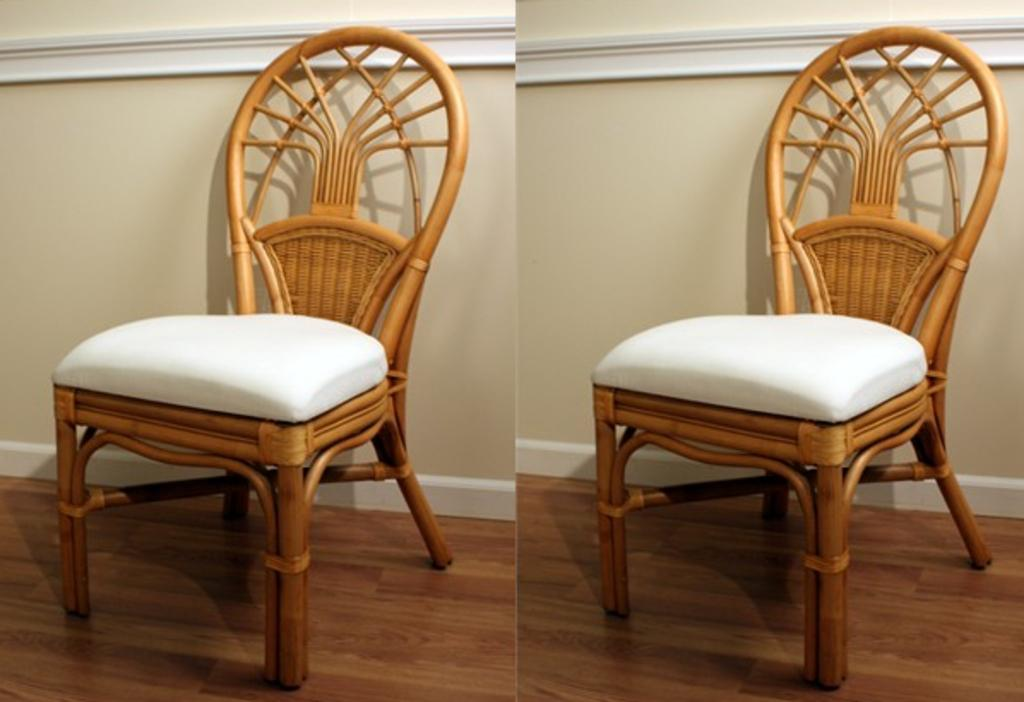What type of chair is in the image? There is a wooden chair in the image. Where is the wooden chair located? The wooden chair is placed on the wooden floor. What can be seen in the background of the image? There is a wall visible in the background of the image. What type of trees can be seen in the store in the image? There is no store or trees present in the image; it features a wooden chair on a wooden floor with a wall visible in the background. 